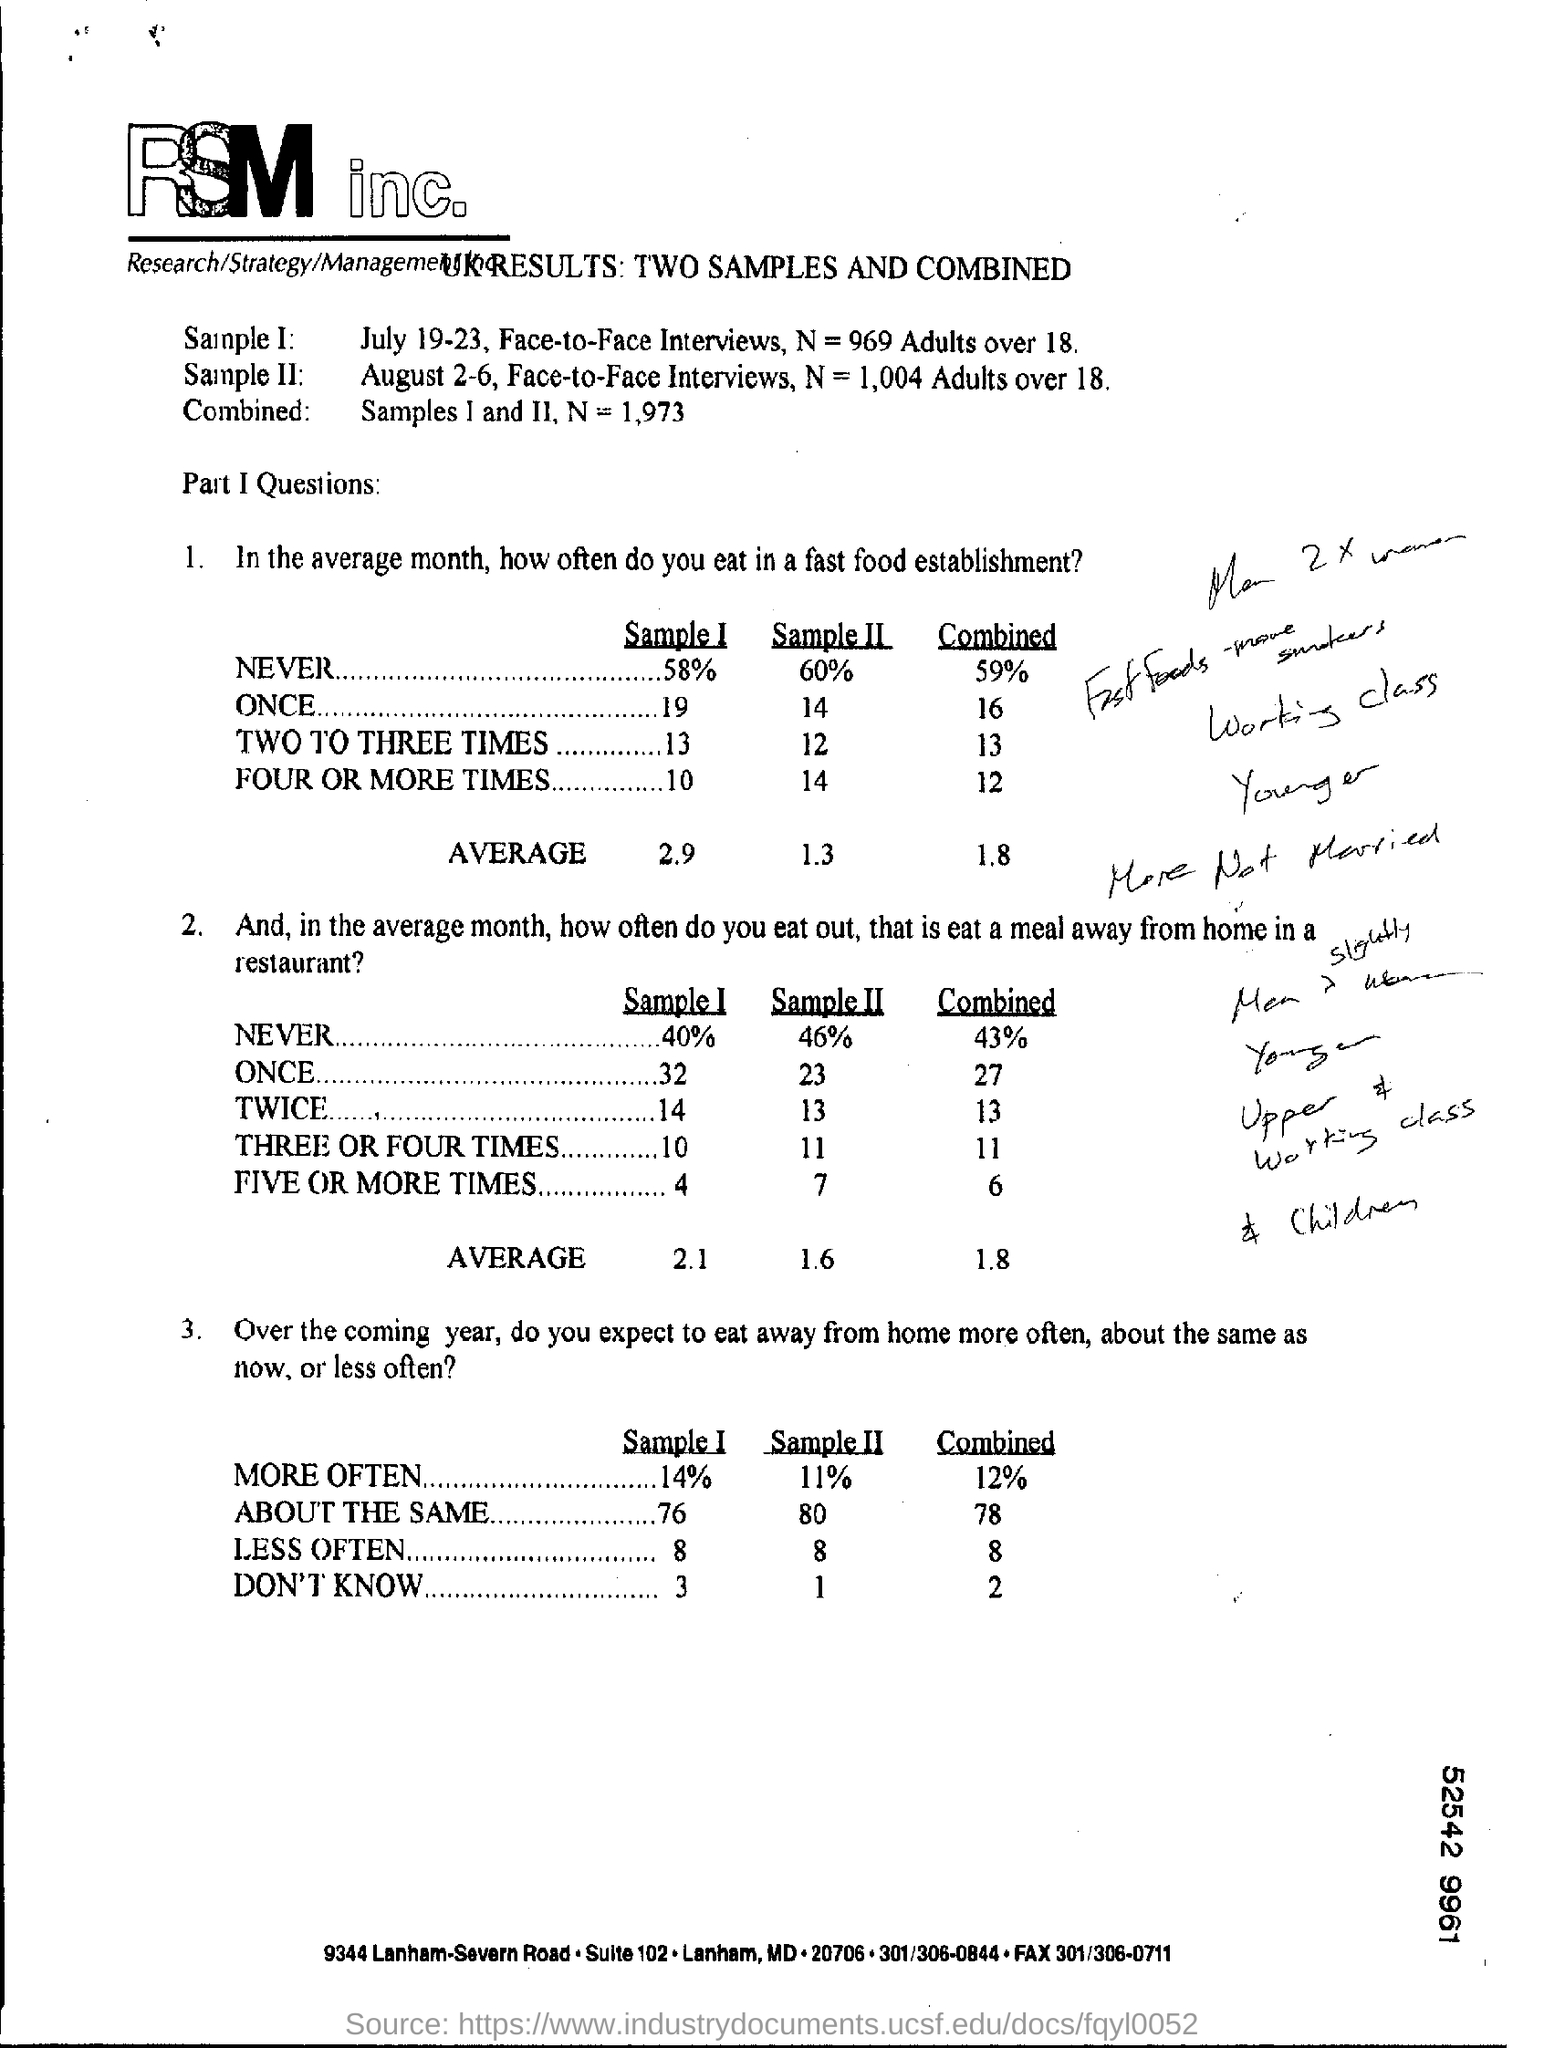What is the Average for Sample I for Question 1.?
Provide a succinct answer. 2.9. 